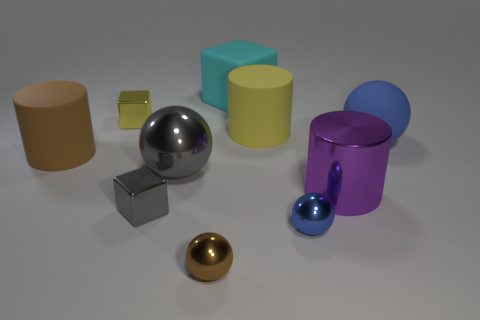Is the shape of the rubber object that is on the left side of the small brown ball the same as  the small blue metallic object?
Your answer should be very brief. No. How many big blocks are the same material as the big blue sphere?
Keep it short and to the point. 1. How many objects are big purple objects that are behind the small blue object or big gray shiny balls?
Provide a short and direct response. 2. The yellow cylinder has what size?
Your response must be concise. Large. The brown object to the left of the brown object that is to the right of the gray metallic sphere is made of what material?
Provide a succinct answer. Rubber. Is the size of the rubber cylinder that is behind the rubber ball the same as the big blue rubber sphere?
Ensure brevity in your answer.  Yes. Is there a small thing of the same color as the shiny cylinder?
Ensure brevity in your answer.  No. What number of things are big rubber cylinders that are behind the blue matte sphere or yellow objects that are behind the yellow cylinder?
Your answer should be very brief. 2. Are there fewer cyan matte objects that are behind the large matte cube than small blocks behind the big brown object?
Offer a very short reply. Yes. Is the material of the cyan block the same as the small gray object?
Your answer should be compact. No. 